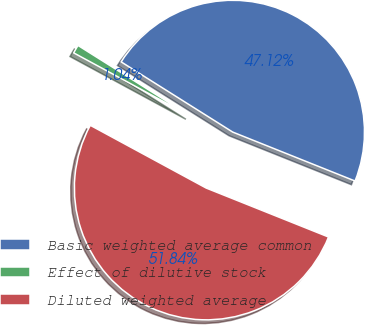Convert chart to OTSL. <chart><loc_0><loc_0><loc_500><loc_500><pie_chart><fcel>Basic weighted average common<fcel>Effect of dilutive stock<fcel>Diluted weighted average<nl><fcel>47.12%<fcel>1.04%<fcel>51.84%<nl></chart> 